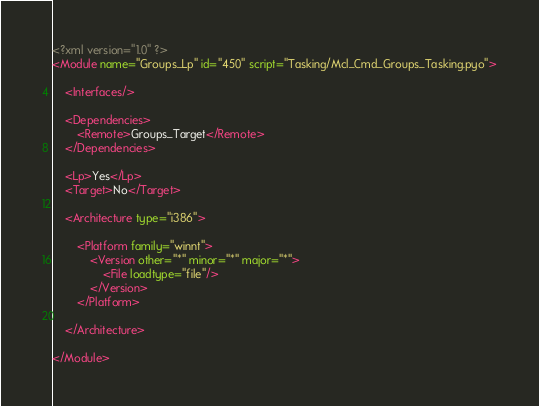<code> <loc_0><loc_0><loc_500><loc_500><_XML_><?xml version="1.0" ?>
<Module name="Groups_Lp" id="450" script="Tasking/Mcl_Cmd_Groups_Tasking.pyo">

	<Interfaces/>

	<Dependencies>
		<Remote>Groups_Target</Remote>
	</Dependencies>

	<Lp>Yes</Lp>
	<Target>No</Target>

	<Architecture type="i386">
	
		<Platform family="winnt">
			<Version other="*" minor="*" major="*">
				<File loadtype="file"/>
			</Version>
		</Platform>

	</Architecture>
	
</Module>
</code> 